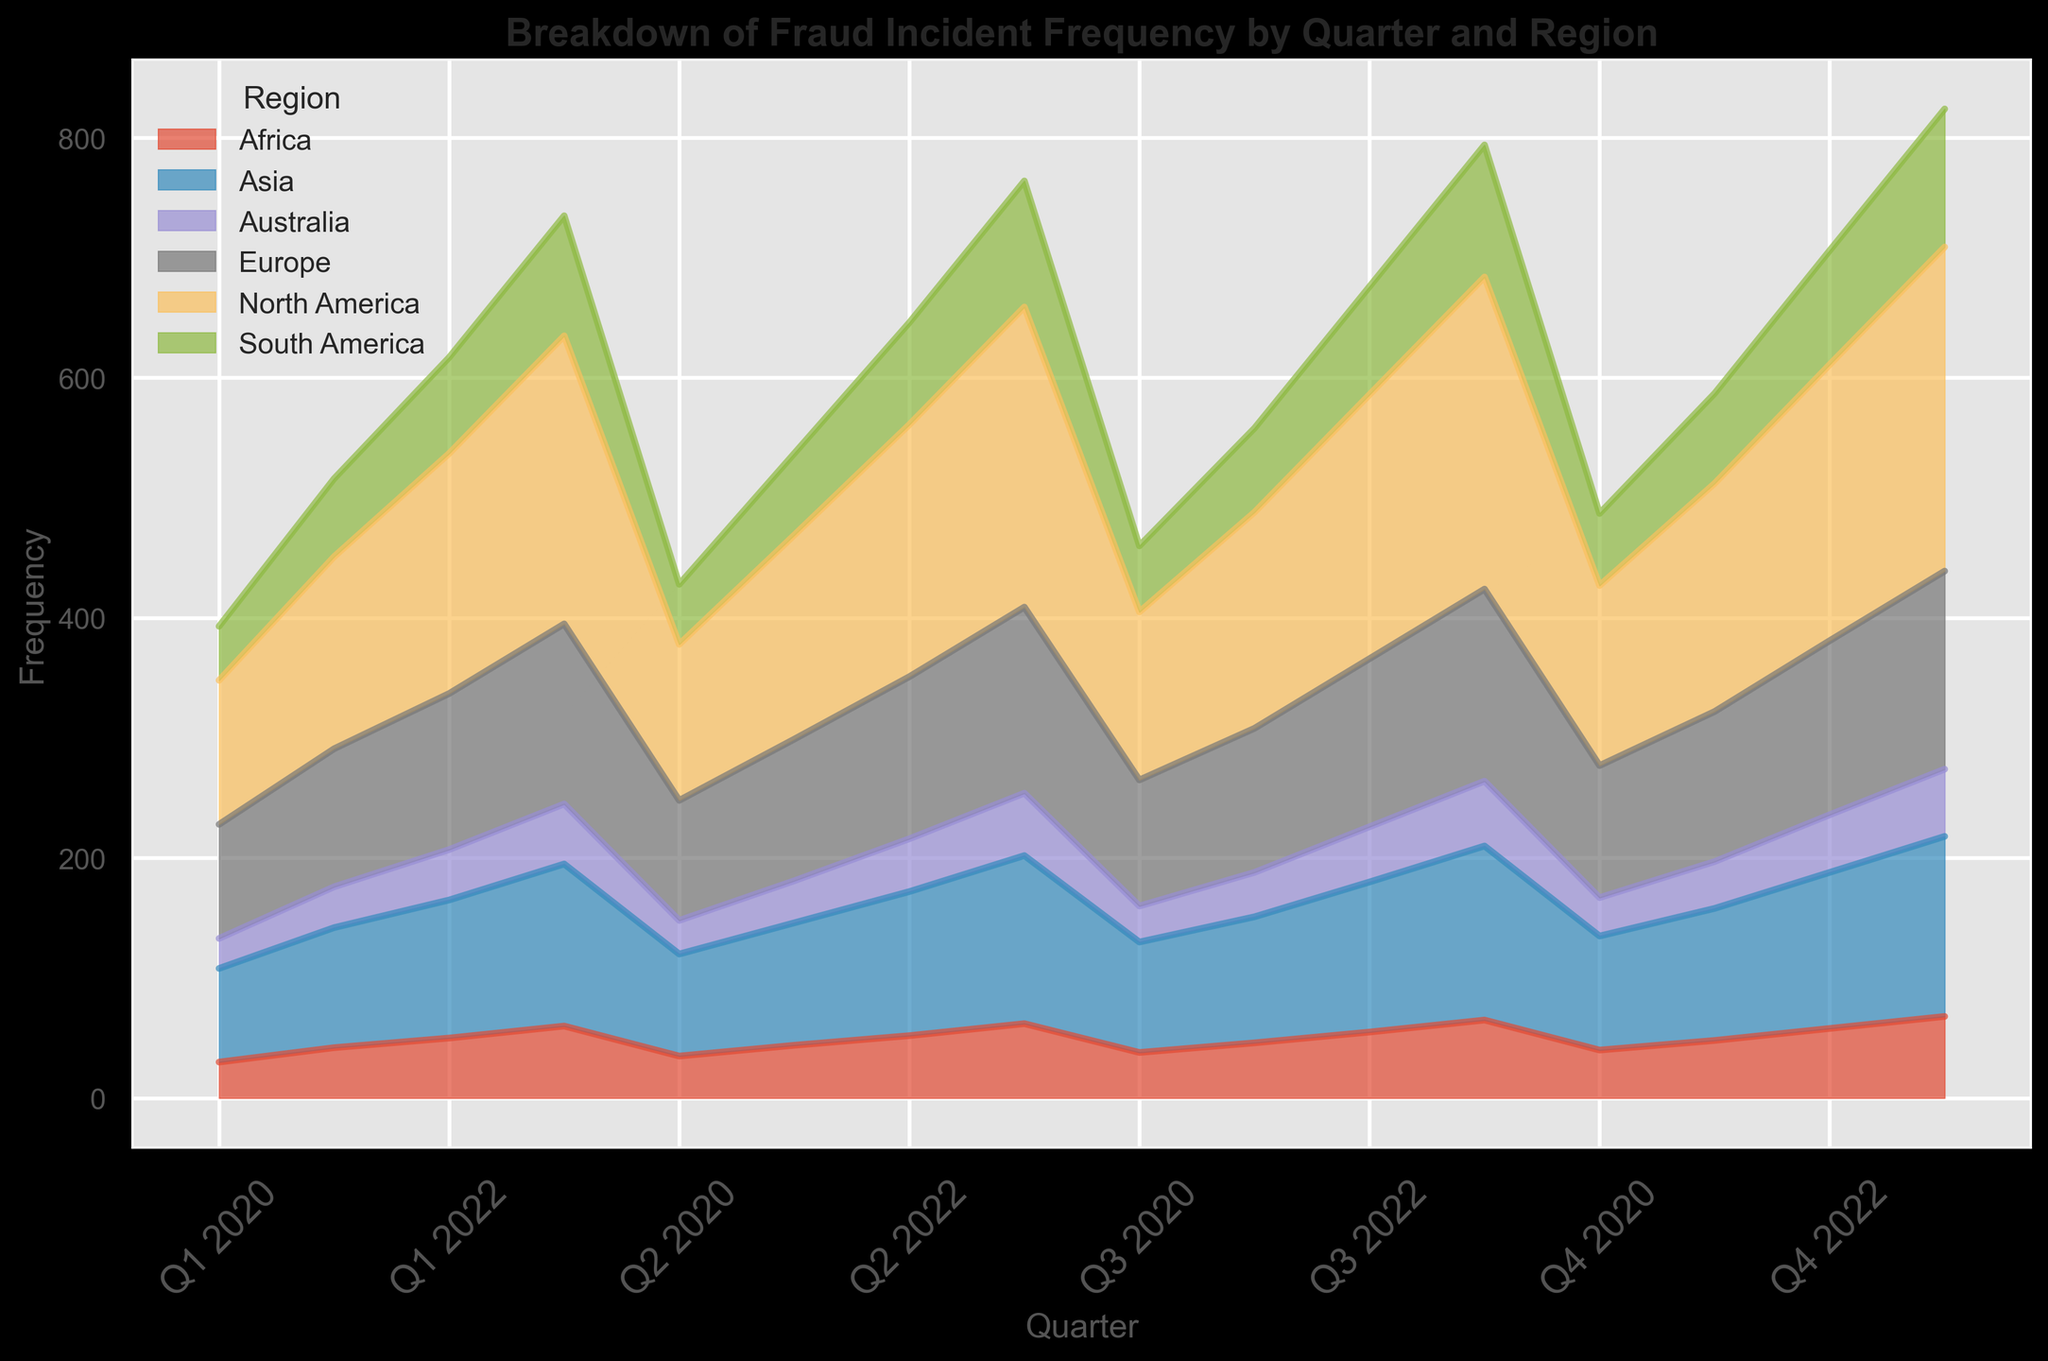What's the trend of fraud incidents in North America over the quarters? The area representing North America is consistently increasing over the quarters, suggesting a rising trend in fraud incidents in this region. Hence, the number of fraud incidents in North America is on the rise from Q1 2020 to Q4 2023.
Answer: Rising trend Which quarter had the highest overall frequency of fraud incidents across all regions? Visually, the figure shows that the height of all combined regions is maximum in Q4 2023. The sum of the areas represented by all regions is the highest in Q4 2023, indicating the highest overall frequency of fraud incidents in this quarter.
Answer: Q4 2023 Compare the trend in fraud incidents between North America and Asia. Which region shows a higher increase over the quarters? North America's area increases significantly more steeply compared to Asia's. From Q1 2020 to Q4 2023, North America's frequency rises from 120 to 270, while Asia's rises from 78 to 150. Therefore, North America's increase is larger.
Answer: North America How does the trend in Europe compare to Australia from Q1 2020 to Q4 2023? While both Europe and Australia show increasing trends, Europe has a steeper and larger increase in fraud incidents. Europe starts lower than Australia in Q1 2020 but surpasses it quickly and continues to diverge. Australia's increase is more gradual.
Answer: Europe has a higher increase Which region had the smallest number of fraud incidents in Q2 2021? Looking at Q2 2021, Australia has the smallest area among all regions, meaning it had the smallest number of fraud incidents.
Answer: Australia Did any region exhibit a stable trend over the given quarters without significant changes? While most regions show an increase in frequency, Australia shows a relatively stable and gradual trend with smaller changes compared to other regions.
Answer: Australia What is the difference in frequency of fraud incidents between Q4 2023 and Q4 2020 for South America? The frequency for South America in Q4 2020 is 60, and in Q4 2023 it is 115. The difference is 115 - 60 = 55.
Answer: 55 What is the approximate total frequency of fraud incidents across all regions in Q4 2022? Summing the frequencies from Q4 2022: North America (230), Europe (145), Asia (130), South America (95), Africa (58), Australia (48). Total = 230 + 145 + 130 + 95 + 58 + 48 = 706.
Answer: 706 